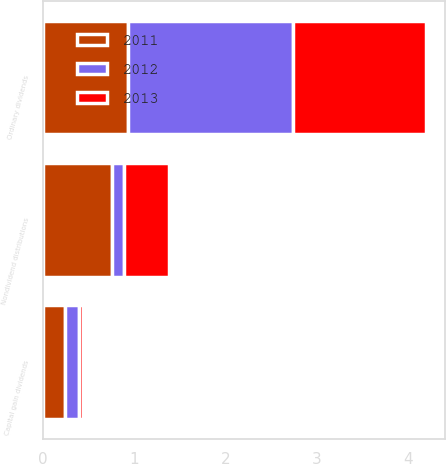Convert chart. <chart><loc_0><loc_0><loc_500><loc_500><stacked_bar_chart><ecel><fcel>Ordinary dividends<fcel>Capital gain dividends<fcel>Nondividend distributions<nl><fcel>2012<fcel>1.81<fcel>0.15<fcel>0.14<nl><fcel>2013<fcel>1.46<fcel>0.05<fcel>0.49<nl><fcel>2011<fcel>0.93<fcel>0.24<fcel>0.75<nl></chart> 